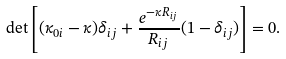<formula> <loc_0><loc_0><loc_500><loc_500>\det \left [ ( \kappa _ { 0 i } - \kappa ) \delta _ { i j } + \frac { e ^ { - \kappa R _ { i j } } } { R _ { i j } } ( 1 - \delta _ { i j } ) \right ] = 0 .</formula> 